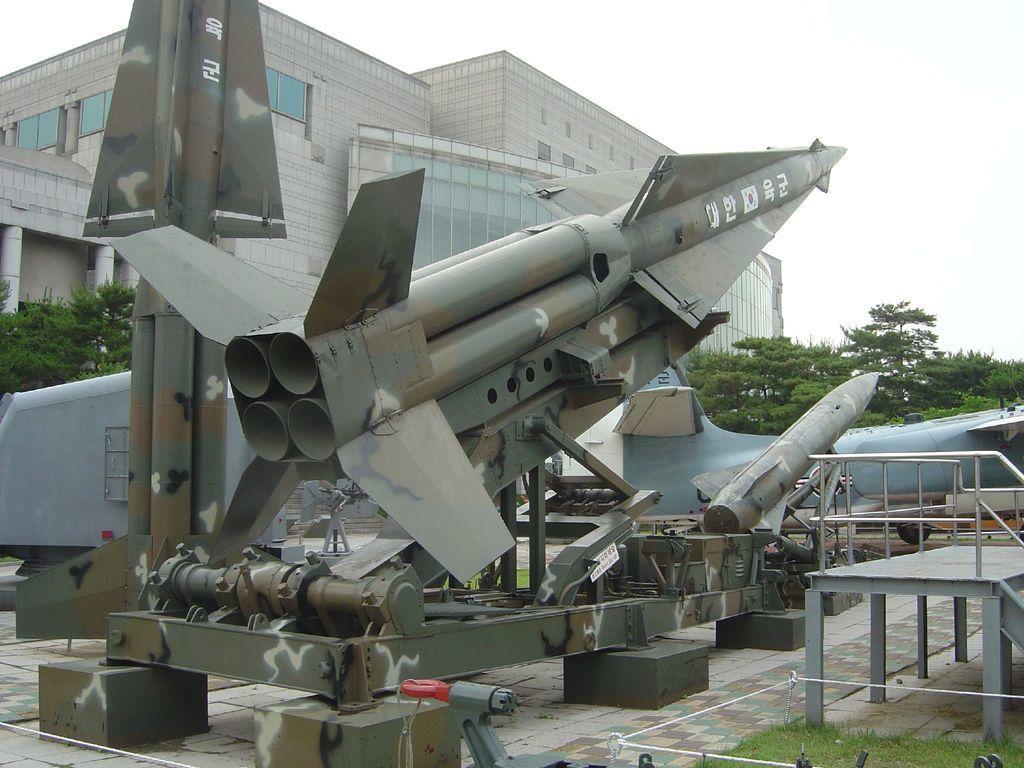Can you describe this image briefly? In the picture there are few missiles kept on the ground and behind the missiles there is a huge building and there are many trees in front of that building. 